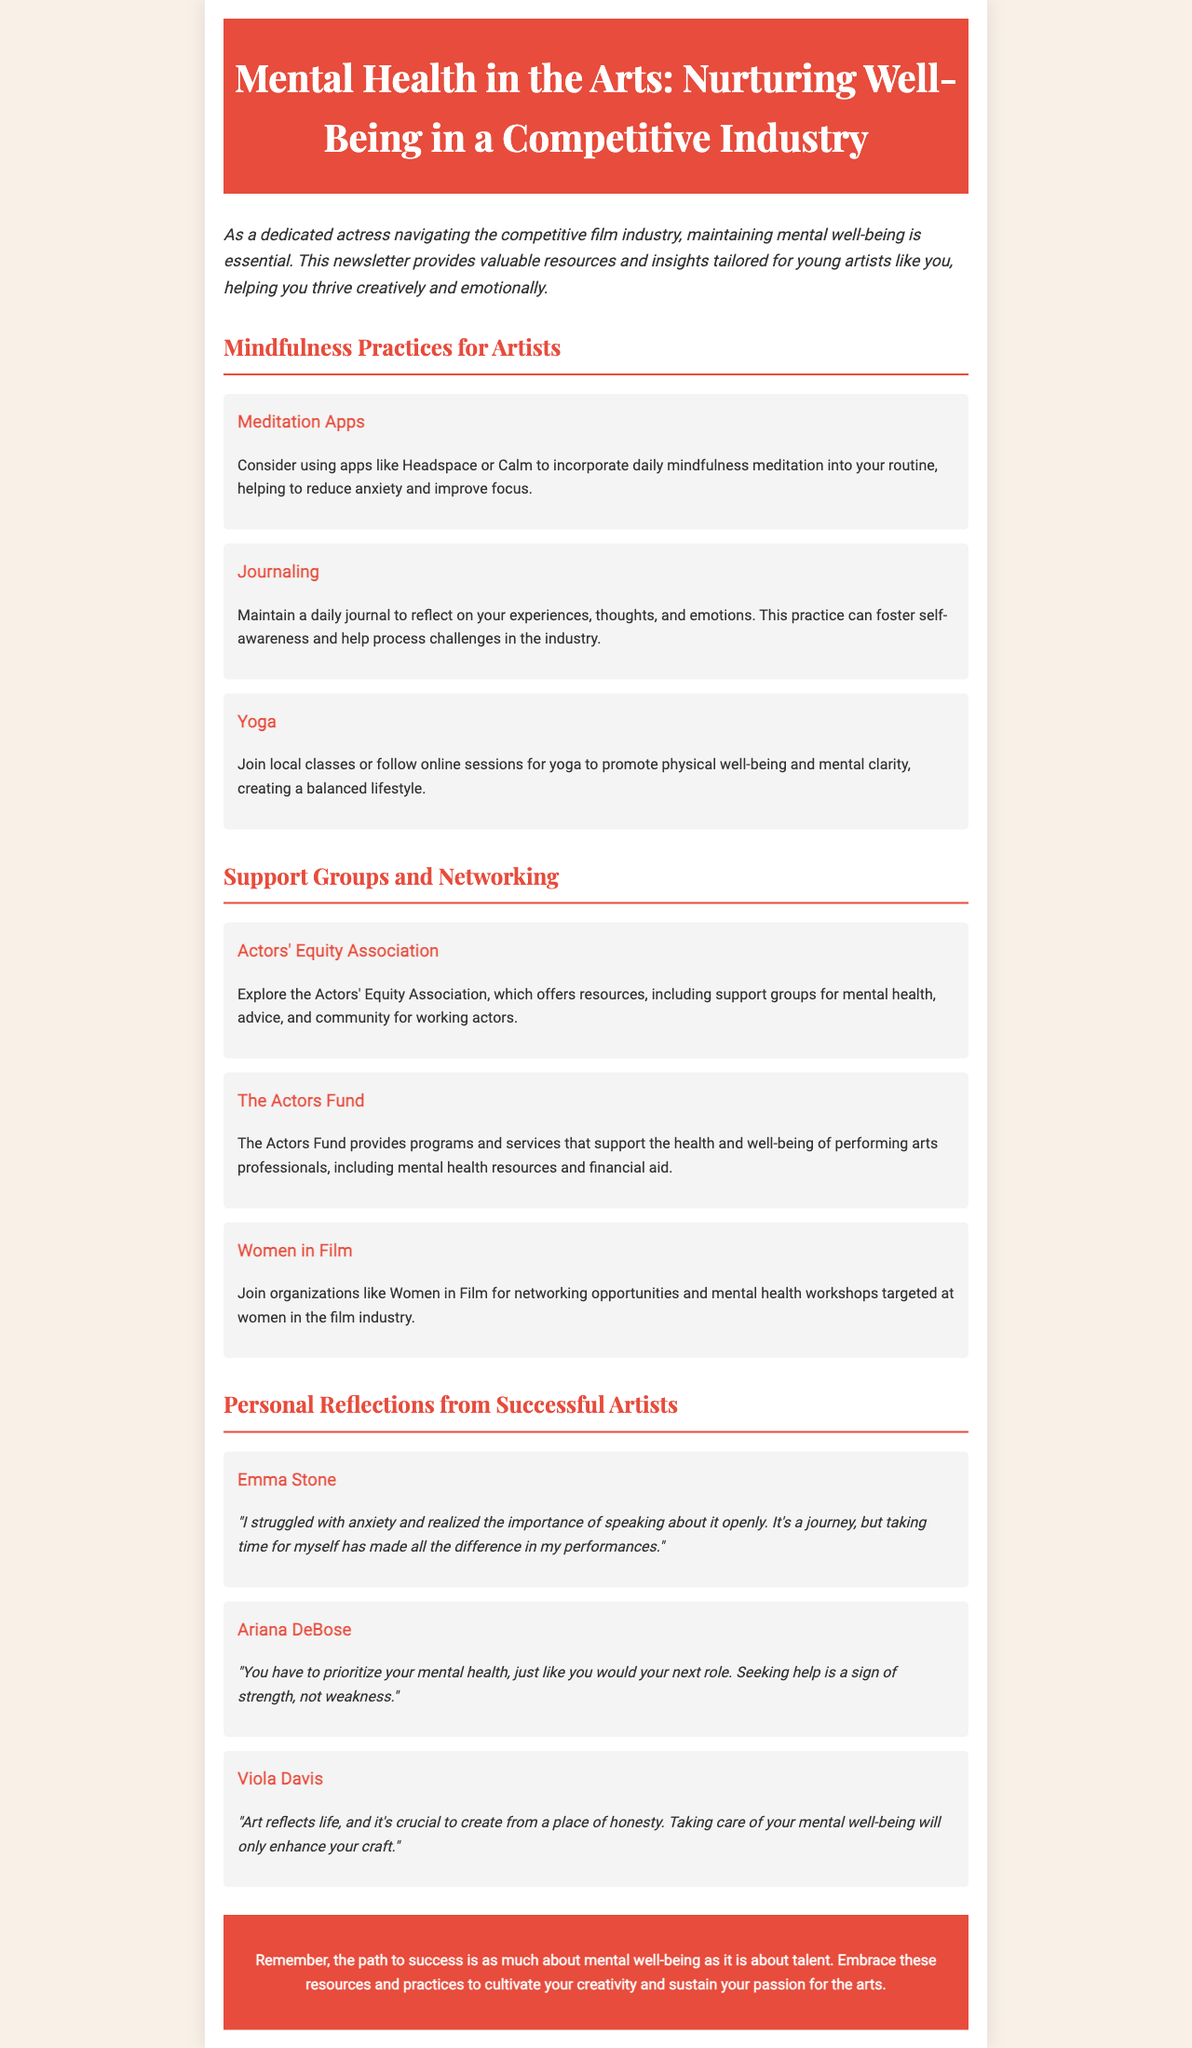What are some mindfulness practices mentioned? The section on mindfulness practices lists specific activities that can help improve mental well-being, such as meditation, journaling, and yoga.
Answer: Meditation, journaling, yoga Which organizations support mental health for artists? The document lists several organizations that provide support and resources, specifically mentioning the Actors' Equity Association, The Actors Fund, and Women in Film.
Answer: Actors' Equity Association, The Actors Fund, Women in Film Who is quoted about prioritizing mental health? The document includes quotes from several artists reflecting on mental health, one of them being Ariana DeBose discussing the importance of prioritizing mental health.
Answer: Ariana DeBose How many mindfulness practices are listed? The document enumerates three specific mindfulness practices that can benefit artists, indicating that there are multiple options.
Answer: 3 Which successful artist mentioned their anxiety struggle? The text includes a personal reflection from Emma Stone, who shares her experience with anxiety and its impact on her performance.
Answer: Emma Stone What is the title of the newsletter? The title is an essential part of the document, indicating its focus on mental health within the artistic community.
Answer: Mental Health in the Arts: Nurturing Well-Being in a Competitive Industry What does Viola Davis say about art and mental well-being? The quote from Viola Davis emphasizes the connection between mental health and the authenticity of art, pointing out the significance of self-care in creativity.
Answer: "Art reflects life, and it's crucial to create from a place of honesty." 